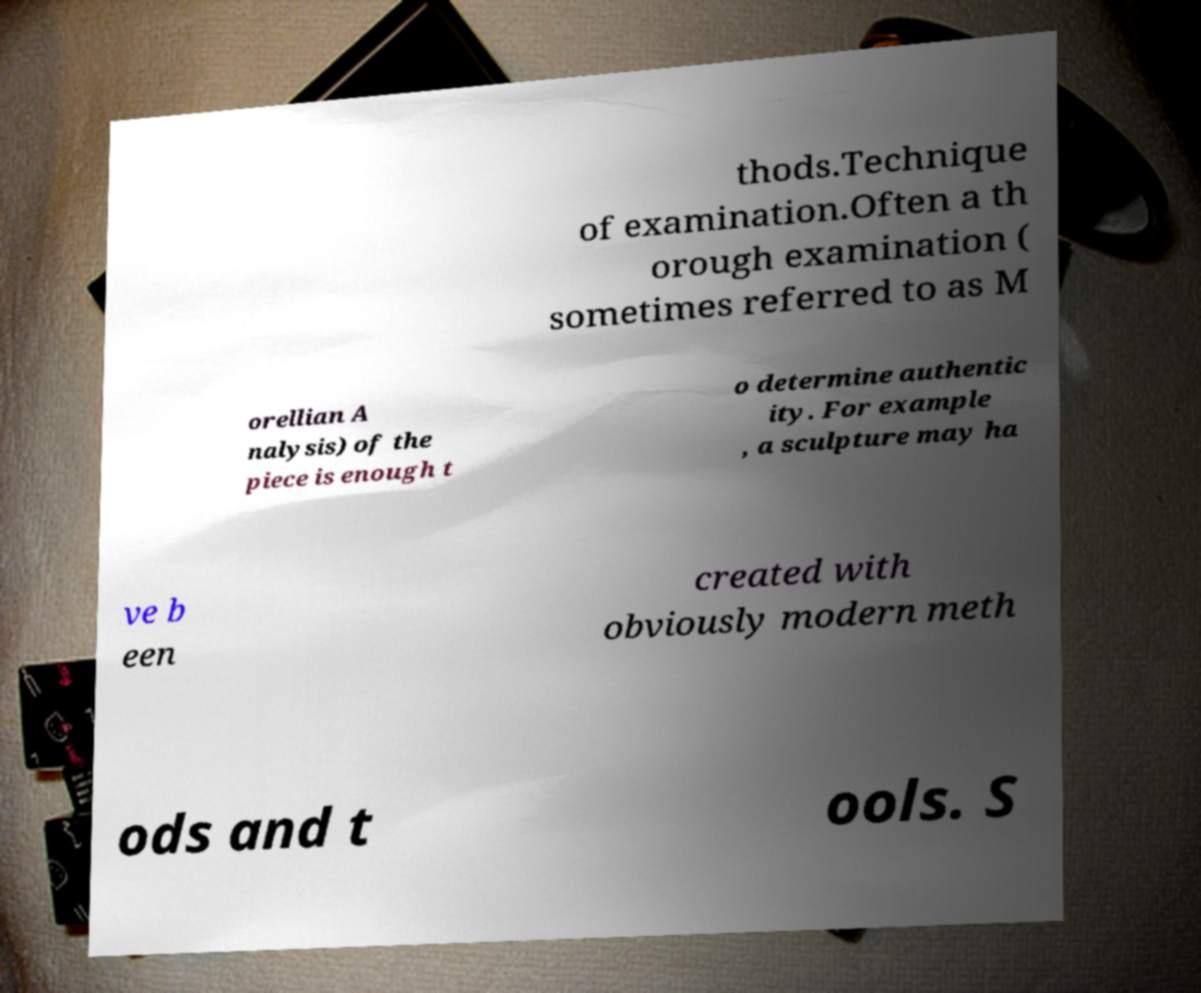Please identify and transcribe the text found in this image. thods.Technique of examination.Often a th orough examination ( sometimes referred to as M orellian A nalysis) of the piece is enough t o determine authentic ity. For example , a sculpture may ha ve b een created with obviously modern meth ods and t ools. S 